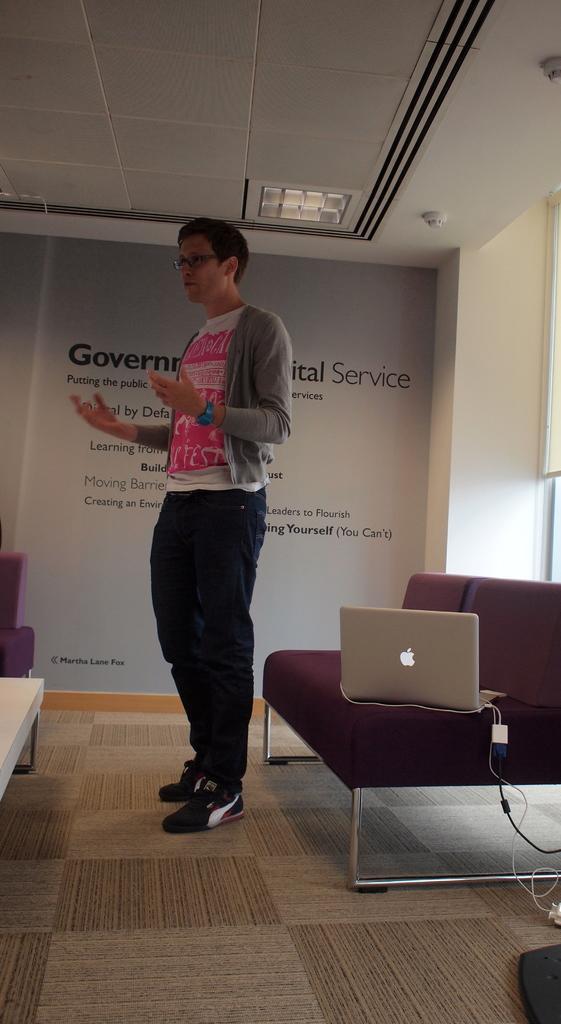Describe this image in one or two sentences. there is a man in the room,there is a sofa on the sofa we can see a laptop present over there with the cables ,there is banner back of the man on the wall with the text. 